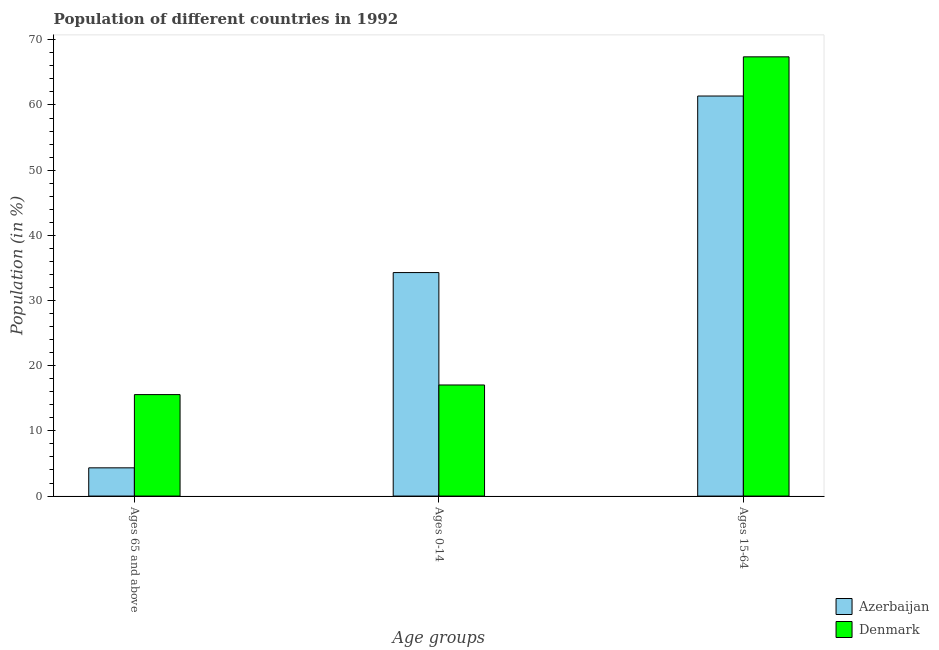Are the number of bars on each tick of the X-axis equal?
Your answer should be very brief. Yes. How many bars are there on the 3rd tick from the right?
Offer a terse response. 2. What is the label of the 2nd group of bars from the left?
Provide a succinct answer. Ages 0-14. What is the percentage of population within the age-group of 65 and above in Azerbaijan?
Your answer should be compact. 4.33. Across all countries, what is the maximum percentage of population within the age-group 15-64?
Offer a terse response. 67.39. Across all countries, what is the minimum percentage of population within the age-group 15-64?
Your answer should be very brief. 61.38. What is the total percentage of population within the age-group 0-14 in the graph?
Your response must be concise. 51.33. What is the difference between the percentage of population within the age-group 15-64 in Azerbaijan and that in Denmark?
Offer a terse response. -6.01. What is the difference between the percentage of population within the age-group 15-64 in Azerbaijan and the percentage of population within the age-group 0-14 in Denmark?
Your response must be concise. 44.33. What is the average percentage of population within the age-group 15-64 per country?
Ensure brevity in your answer.  64.38. What is the difference between the percentage of population within the age-group 0-14 and percentage of population within the age-group 15-64 in Azerbaijan?
Your answer should be very brief. -27.09. What is the ratio of the percentage of population within the age-group 15-64 in Azerbaijan to that in Denmark?
Your answer should be compact. 0.91. Is the percentage of population within the age-group 0-14 in Denmark less than that in Azerbaijan?
Give a very brief answer. Yes. What is the difference between the highest and the second highest percentage of population within the age-group 15-64?
Offer a terse response. 6.01. What is the difference between the highest and the lowest percentage of population within the age-group 15-64?
Provide a succinct answer. 6.01. In how many countries, is the percentage of population within the age-group of 65 and above greater than the average percentage of population within the age-group of 65 and above taken over all countries?
Your answer should be very brief. 1. What does the 1st bar from the left in Ages 0-14 represents?
Your answer should be compact. Azerbaijan. What does the 2nd bar from the right in Ages 0-14 represents?
Ensure brevity in your answer.  Azerbaijan. Are all the bars in the graph horizontal?
Offer a very short reply. No. Are the values on the major ticks of Y-axis written in scientific E-notation?
Give a very brief answer. No. Does the graph contain grids?
Provide a short and direct response. No. Where does the legend appear in the graph?
Keep it short and to the point. Bottom right. How many legend labels are there?
Offer a terse response. 2. What is the title of the graph?
Make the answer very short. Population of different countries in 1992. Does "Faeroe Islands" appear as one of the legend labels in the graph?
Offer a very short reply. No. What is the label or title of the X-axis?
Ensure brevity in your answer.  Age groups. What is the label or title of the Y-axis?
Your response must be concise. Population (in %). What is the Population (in %) of Azerbaijan in Ages 65 and above?
Your response must be concise. 4.33. What is the Population (in %) of Denmark in Ages 65 and above?
Give a very brief answer. 15.57. What is the Population (in %) of Azerbaijan in Ages 0-14?
Offer a terse response. 34.29. What is the Population (in %) of Denmark in Ages 0-14?
Keep it short and to the point. 17.04. What is the Population (in %) of Azerbaijan in Ages 15-64?
Your response must be concise. 61.38. What is the Population (in %) of Denmark in Ages 15-64?
Your answer should be compact. 67.39. Across all Age groups, what is the maximum Population (in %) of Azerbaijan?
Make the answer very short. 61.38. Across all Age groups, what is the maximum Population (in %) of Denmark?
Keep it short and to the point. 67.39. Across all Age groups, what is the minimum Population (in %) of Azerbaijan?
Keep it short and to the point. 4.33. Across all Age groups, what is the minimum Population (in %) in Denmark?
Provide a succinct answer. 15.57. What is the total Population (in %) in Azerbaijan in the graph?
Make the answer very short. 100. What is the difference between the Population (in %) in Azerbaijan in Ages 65 and above and that in Ages 0-14?
Offer a very short reply. -29.96. What is the difference between the Population (in %) of Denmark in Ages 65 and above and that in Ages 0-14?
Make the answer very short. -1.48. What is the difference between the Population (in %) in Azerbaijan in Ages 65 and above and that in Ages 15-64?
Offer a very short reply. -57.05. What is the difference between the Population (in %) of Denmark in Ages 65 and above and that in Ages 15-64?
Make the answer very short. -51.82. What is the difference between the Population (in %) in Azerbaijan in Ages 0-14 and that in Ages 15-64?
Ensure brevity in your answer.  -27.09. What is the difference between the Population (in %) in Denmark in Ages 0-14 and that in Ages 15-64?
Offer a very short reply. -50.35. What is the difference between the Population (in %) of Azerbaijan in Ages 65 and above and the Population (in %) of Denmark in Ages 0-14?
Give a very brief answer. -12.71. What is the difference between the Population (in %) of Azerbaijan in Ages 65 and above and the Population (in %) of Denmark in Ages 15-64?
Provide a short and direct response. -63.06. What is the difference between the Population (in %) in Azerbaijan in Ages 0-14 and the Population (in %) in Denmark in Ages 15-64?
Offer a very short reply. -33.1. What is the average Population (in %) in Azerbaijan per Age groups?
Provide a succinct answer. 33.33. What is the average Population (in %) of Denmark per Age groups?
Your answer should be very brief. 33.33. What is the difference between the Population (in %) in Azerbaijan and Population (in %) in Denmark in Ages 65 and above?
Make the answer very short. -11.24. What is the difference between the Population (in %) of Azerbaijan and Population (in %) of Denmark in Ages 0-14?
Offer a terse response. 17.25. What is the difference between the Population (in %) of Azerbaijan and Population (in %) of Denmark in Ages 15-64?
Offer a terse response. -6.01. What is the ratio of the Population (in %) of Azerbaijan in Ages 65 and above to that in Ages 0-14?
Ensure brevity in your answer.  0.13. What is the ratio of the Population (in %) of Denmark in Ages 65 and above to that in Ages 0-14?
Make the answer very short. 0.91. What is the ratio of the Population (in %) in Azerbaijan in Ages 65 and above to that in Ages 15-64?
Offer a terse response. 0.07. What is the ratio of the Population (in %) of Denmark in Ages 65 and above to that in Ages 15-64?
Ensure brevity in your answer.  0.23. What is the ratio of the Population (in %) of Azerbaijan in Ages 0-14 to that in Ages 15-64?
Give a very brief answer. 0.56. What is the ratio of the Population (in %) in Denmark in Ages 0-14 to that in Ages 15-64?
Your response must be concise. 0.25. What is the difference between the highest and the second highest Population (in %) in Azerbaijan?
Your answer should be compact. 27.09. What is the difference between the highest and the second highest Population (in %) in Denmark?
Offer a very short reply. 50.35. What is the difference between the highest and the lowest Population (in %) of Azerbaijan?
Provide a succinct answer. 57.05. What is the difference between the highest and the lowest Population (in %) of Denmark?
Offer a terse response. 51.82. 